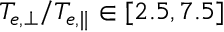<formula> <loc_0><loc_0><loc_500><loc_500>T _ { e , \perp } / T _ { e , \| } \in [ 2 . 5 , 7 . 5 ]</formula> 